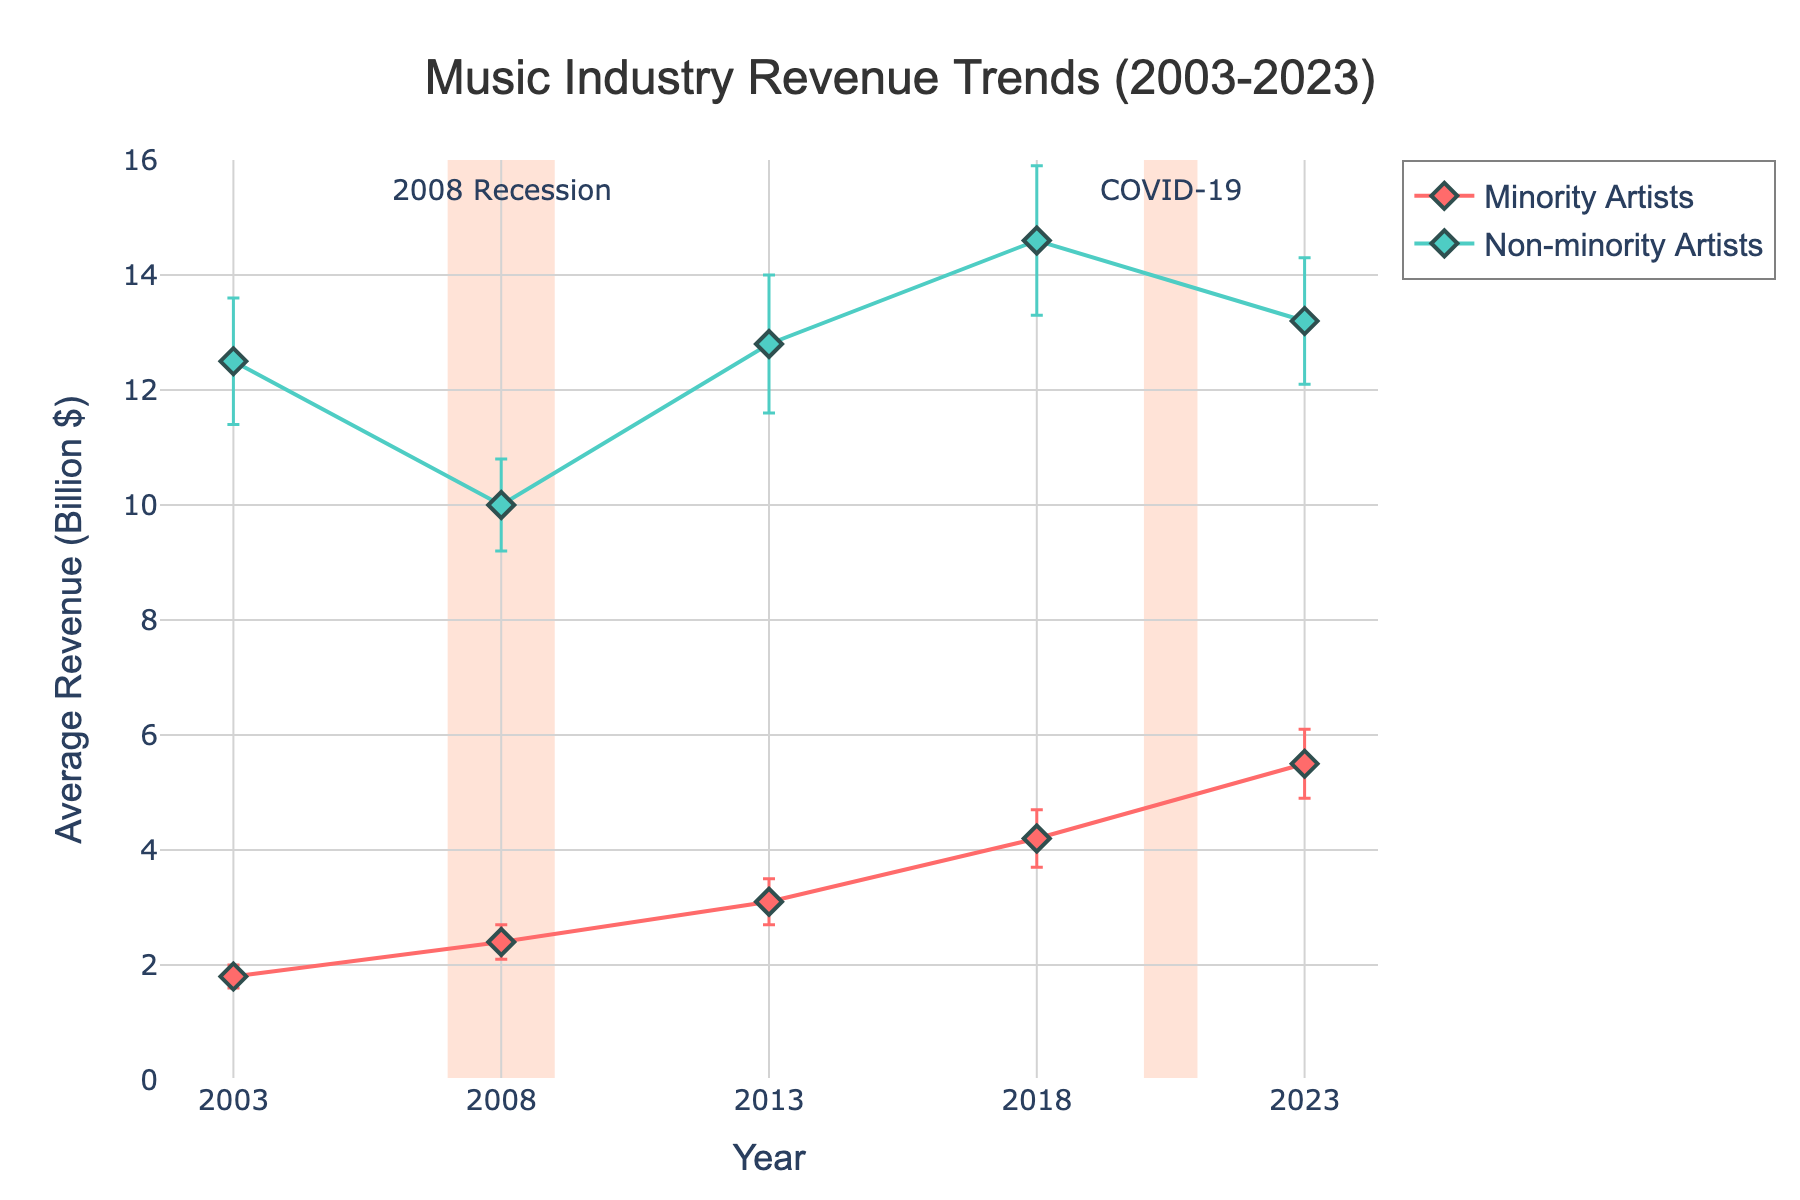Which category saw a larger increase in average revenue between 2018 and 2023? To find the category with the larger increase, note the average revenue in 2018 and 2023: Minority Artists (4.2 to 5.5) and Non-minority Artists (14.6 to 13.2). Calculate the increase for Minority Artists (5.5 - 4.2 = 1.3) and for Non-minority Artists (13.2 - 14.6 = -1.4). Minority Artists had a larger increase.
Answer: Minority Artists What is the overall trend for minority artists' average revenue from 2003 to 2023? Observe the data points for Minority Artists over the years: 2003 (1.8), 2008 (2.4), 2013 (3.1), 2018 (4.2), and 2023 (5.5). All points show an increase, indicating a rising trend.
Answer: Increasing During the 2008 recession, how did the revenue for non-minority artists change compared to 2003? Look at the non-minority artist revenues in 2003 (12.5) and 2008 (10.0). Calculate the change: 10.0 - 12.5 = -2.5. Revenue decreased by 2.5 billion dollars.
Answer: Decreased by 2.5 billion dollars Comparing data from the COVID-19 period (2020-2021) with the 2008 recession, which period had a more prominent impact on non-minority artists' revenue? Since the exact figures for 2020 are provided, check around 2020 to 2023 data and compare: Non-minority Artists had 14.6 in 2018, decreased to 13.2 in 2023. For the 2008 recession, it was 12.5 in 2003 to 10.0 in 2008. The 2008 recession caused a larger percentage drop.
Answer: 2008 recession What is the error margin for minority artists’ revenue in 2013? Locate the value of standard deviation for Minority Artists in 2013, which is 0.4. This indicates the error margin.
Answer: 0.4 In which year did minority artists' average revenue first exceed 2 billion dollars? Look at the data points and identify the year when the revenue for Minority Artists first surpassed 2 billion: 2003 (1.8), 2008 (2.4). Therefore, 2008 is the year.
Answer: 2008 Which economic downturn period saw a larger error margin in the revenue of minority artists? Compare the error margins for Minority Artists in the given downturn periods: 2008 (0.3) and around 2020-2021, the closest data being 2023 (0.6). The COVID-19 period had a larger error margin.
Answer: COVID-19 period How did the average revenue for non-minority artists change from 2013 to 2018? Look at the non-minority artist revenues in 2013 (12.8) and 2018 (14.6). Calculate the change: 14.6 - 12.8 = 1.8 billion dollars.
Answer: Increased by 1.8 billion dollars Did the average revenue for minority artists ever decrease in any of the reported years? Review yearly minority artists' revenues: 2003 (1.8), 2008 (2.4), 2013 (3.1), 2018 (4.2), and 2023 (5.5). All recorded revenues increased over time.
Answer: No 